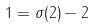Convert formula to latex. <formula><loc_0><loc_0><loc_500><loc_500>1 = \sigma ( 2 ) - 2</formula> 